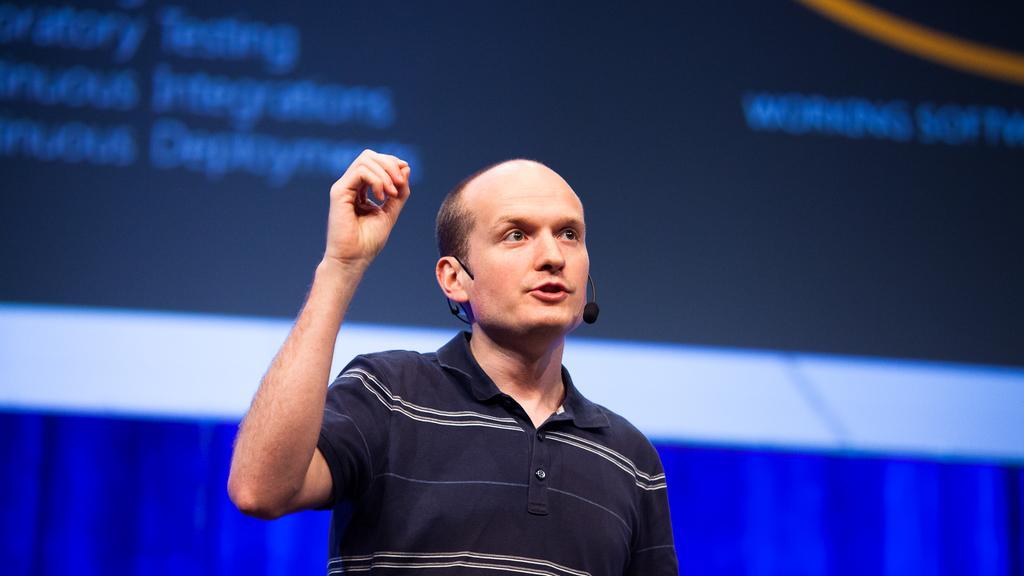Can you describe this image briefly? Here we can see a man talking on the mike. In the background there is a cloth and a banner. 